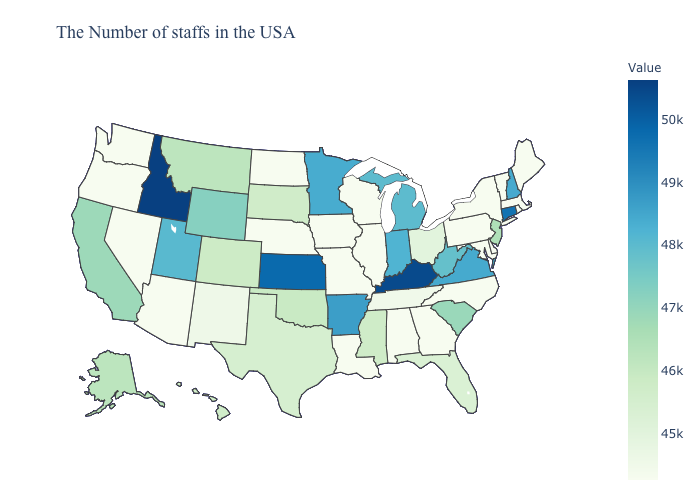Does Ohio have the lowest value in the MidWest?
Write a very short answer. No. Among the states that border Arizona , does Nevada have the lowest value?
Be succinct. Yes. Does West Virginia have the highest value in the USA?
Short answer required. No. 